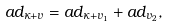<formula> <loc_0><loc_0><loc_500><loc_500>a d _ { \kappa + v } = a d _ { \kappa + v _ { 1 } } + a d _ { v _ { 2 } } ,</formula> 